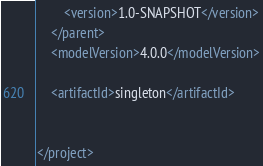<code> <loc_0><loc_0><loc_500><loc_500><_XML_>        <version>1.0-SNAPSHOT</version>
    </parent>
    <modelVersion>4.0.0</modelVersion>

    <artifactId>singleton</artifactId>


</project></code> 